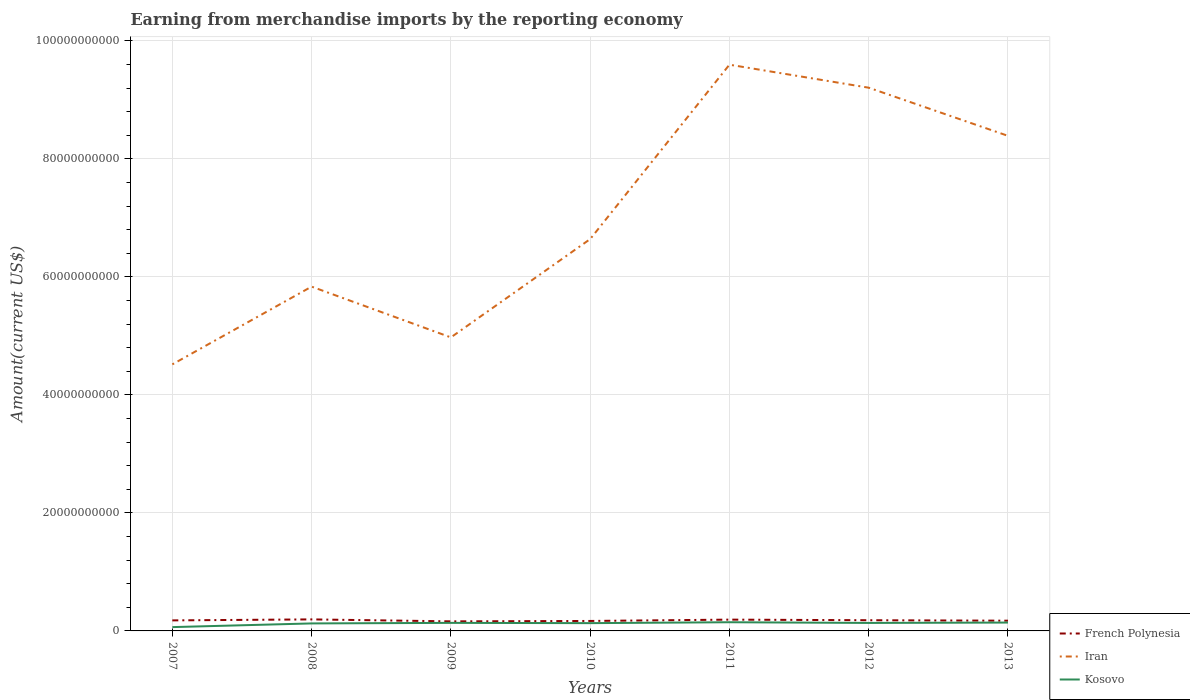How many different coloured lines are there?
Ensure brevity in your answer.  3. Is the number of lines equal to the number of legend labels?
Provide a succinct answer. Yes. Across all years, what is the maximum amount earned from merchandise imports in Iran?
Your response must be concise. 4.52e+1. What is the total amount earned from merchandise imports in Kosovo in the graph?
Your answer should be compact. -7.72e+08. What is the difference between the highest and the second highest amount earned from merchandise imports in French Polynesia?
Ensure brevity in your answer.  3.34e+08. Is the amount earned from merchandise imports in Kosovo strictly greater than the amount earned from merchandise imports in Iran over the years?
Offer a terse response. Yes. How many lines are there?
Your answer should be very brief. 3. What is the difference between two consecutive major ticks on the Y-axis?
Your response must be concise. 2.00e+1. Does the graph contain any zero values?
Your answer should be very brief. No. How many legend labels are there?
Give a very brief answer. 3. How are the legend labels stacked?
Provide a short and direct response. Vertical. What is the title of the graph?
Your answer should be compact. Earning from merchandise imports by the reporting economy. Does "Uganda" appear as one of the legend labels in the graph?
Your answer should be compact. No. What is the label or title of the Y-axis?
Your answer should be very brief. Amount(current US$). What is the Amount(current US$) of French Polynesia in 2007?
Provide a short and direct response. 1.78e+09. What is the Amount(current US$) of Iran in 2007?
Give a very brief answer. 4.52e+1. What is the Amount(current US$) of Kosovo in 2007?
Your answer should be very brief. 6.45e+08. What is the Amount(current US$) of French Polynesia in 2008?
Provide a succinct answer. 1.95e+09. What is the Amount(current US$) of Iran in 2008?
Your response must be concise. 5.83e+1. What is the Amount(current US$) of Kosovo in 2008?
Give a very brief answer. 1.27e+09. What is the Amount(current US$) in French Polynesia in 2009?
Your answer should be very brief. 1.62e+09. What is the Amount(current US$) of Iran in 2009?
Offer a very short reply. 4.97e+1. What is the Amount(current US$) in Kosovo in 2009?
Keep it short and to the point. 1.36e+09. What is the Amount(current US$) in French Polynesia in 2010?
Give a very brief answer. 1.69e+09. What is the Amount(current US$) in Iran in 2010?
Provide a short and direct response. 6.64e+1. What is the Amount(current US$) in Kosovo in 2010?
Your response must be concise. 1.32e+09. What is the Amount(current US$) of French Polynesia in 2011?
Offer a very short reply. 1.91e+09. What is the Amount(current US$) of Iran in 2011?
Ensure brevity in your answer.  9.59e+1. What is the Amount(current US$) in Kosovo in 2011?
Provide a succinct answer. 1.47e+09. What is the Amount(current US$) in French Polynesia in 2012?
Your answer should be very brief. 1.81e+09. What is the Amount(current US$) in Iran in 2012?
Offer a very short reply. 9.21e+1. What is the Amount(current US$) of Kosovo in 2012?
Offer a very short reply. 1.35e+09. What is the Amount(current US$) of French Polynesia in 2013?
Give a very brief answer. 1.73e+09. What is the Amount(current US$) in Iran in 2013?
Your response must be concise. 8.39e+1. What is the Amount(current US$) in Kosovo in 2013?
Give a very brief answer. 1.42e+09. Across all years, what is the maximum Amount(current US$) in French Polynesia?
Your answer should be compact. 1.95e+09. Across all years, what is the maximum Amount(current US$) in Iran?
Provide a succinct answer. 9.59e+1. Across all years, what is the maximum Amount(current US$) of Kosovo?
Offer a very short reply. 1.47e+09. Across all years, what is the minimum Amount(current US$) of French Polynesia?
Ensure brevity in your answer.  1.62e+09. Across all years, what is the minimum Amount(current US$) in Iran?
Your response must be concise. 4.52e+1. Across all years, what is the minimum Amount(current US$) of Kosovo?
Make the answer very short. 6.45e+08. What is the total Amount(current US$) of French Polynesia in the graph?
Provide a succinct answer. 1.25e+1. What is the total Amount(current US$) in Iran in the graph?
Ensure brevity in your answer.  4.92e+11. What is the total Amount(current US$) of Kosovo in the graph?
Provide a short and direct response. 8.84e+09. What is the difference between the Amount(current US$) in French Polynesia in 2007 and that in 2008?
Ensure brevity in your answer.  -1.70e+08. What is the difference between the Amount(current US$) of Iran in 2007 and that in 2008?
Offer a terse response. -1.32e+1. What is the difference between the Amount(current US$) of Kosovo in 2007 and that in 2008?
Your answer should be compact. -6.26e+08. What is the difference between the Amount(current US$) in French Polynesia in 2007 and that in 2009?
Ensure brevity in your answer.  1.64e+08. What is the difference between the Amount(current US$) in Iran in 2007 and that in 2009?
Your answer should be compact. -4.57e+09. What is the difference between the Amount(current US$) in Kosovo in 2007 and that in 2009?
Keep it short and to the point. -7.19e+08. What is the difference between the Amount(current US$) in French Polynesia in 2007 and that in 2010?
Your answer should be very brief. 9.64e+07. What is the difference between the Amount(current US$) in Iran in 2007 and that in 2010?
Ensure brevity in your answer.  -2.12e+1. What is the difference between the Amount(current US$) of Kosovo in 2007 and that in 2010?
Your answer should be compact. -6.74e+08. What is the difference between the Amount(current US$) of French Polynesia in 2007 and that in 2011?
Provide a succinct answer. -1.29e+08. What is the difference between the Amount(current US$) in Iran in 2007 and that in 2011?
Offer a terse response. -5.08e+1. What is the difference between the Amount(current US$) in Kosovo in 2007 and that in 2011?
Your answer should be very brief. -8.27e+08. What is the difference between the Amount(current US$) in French Polynesia in 2007 and that in 2012?
Make the answer very short. -2.76e+07. What is the difference between the Amount(current US$) of Iran in 2007 and that in 2012?
Make the answer very short. -4.69e+1. What is the difference between the Amount(current US$) in Kosovo in 2007 and that in 2012?
Offer a very short reply. -7.07e+08. What is the difference between the Amount(current US$) in French Polynesia in 2007 and that in 2013?
Your answer should be very brief. 5.14e+07. What is the difference between the Amount(current US$) of Iran in 2007 and that in 2013?
Provide a short and direct response. -3.87e+1. What is the difference between the Amount(current US$) of Kosovo in 2007 and that in 2013?
Make the answer very short. -7.72e+08. What is the difference between the Amount(current US$) in French Polynesia in 2008 and that in 2009?
Offer a terse response. 3.34e+08. What is the difference between the Amount(current US$) in Iran in 2008 and that in 2009?
Provide a short and direct response. 8.60e+09. What is the difference between the Amount(current US$) of Kosovo in 2008 and that in 2009?
Ensure brevity in your answer.  -9.32e+07. What is the difference between the Amount(current US$) in French Polynesia in 2008 and that in 2010?
Ensure brevity in your answer.  2.66e+08. What is the difference between the Amount(current US$) in Iran in 2008 and that in 2010?
Offer a very short reply. -8.05e+09. What is the difference between the Amount(current US$) of Kosovo in 2008 and that in 2010?
Keep it short and to the point. -4.82e+07. What is the difference between the Amount(current US$) in French Polynesia in 2008 and that in 2011?
Provide a short and direct response. 4.01e+07. What is the difference between the Amount(current US$) in Iran in 2008 and that in 2011?
Offer a terse response. -3.76e+1. What is the difference between the Amount(current US$) of Kosovo in 2008 and that in 2011?
Provide a succinct answer. -2.01e+08. What is the difference between the Amount(current US$) in French Polynesia in 2008 and that in 2012?
Provide a short and direct response. 1.42e+08. What is the difference between the Amount(current US$) of Iran in 2008 and that in 2012?
Give a very brief answer. -3.37e+1. What is the difference between the Amount(current US$) of Kosovo in 2008 and that in 2012?
Your response must be concise. -8.09e+07. What is the difference between the Amount(current US$) in French Polynesia in 2008 and that in 2013?
Your answer should be compact. 2.21e+08. What is the difference between the Amount(current US$) in Iran in 2008 and that in 2013?
Provide a short and direct response. -2.55e+1. What is the difference between the Amount(current US$) in Kosovo in 2008 and that in 2013?
Offer a very short reply. -1.46e+08. What is the difference between the Amount(current US$) of French Polynesia in 2009 and that in 2010?
Your answer should be compact. -6.78e+07. What is the difference between the Amount(current US$) of Iran in 2009 and that in 2010?
Make the answer very short. -1.67e+1. What is the difference between the Amount(current US$) of Kosovo in 2009 and that in 2010?
Offer a very short reply. 4.51e+07. What is the difference between the Amount(current US$) of French Polynesia in 2009 and that in 2011?
Make the answer very short. -2.94e+08. What is the difference between the Amount(current US$) of Iran in 2009 and that in 2011?
Your answer should be compact. -4.62e+1. What is the difference between the Amount(current US$) in Kosovo in 2009 and that in 2011?
Offer a very short reply. -1.08e+08. What is the difference between the Amount(current US$) in French Polynesia in 2009 and that in 2012?
Provide a succinct answer. -1.92e+08. What is the difference between the Amount(current US$) in Iran in 2009 and that in 2012?
Your answer should be compact. -4.23e+1. What is the difference between the Amount(current US$) in Kosovo in 2009 and that in 2012?
Provide a short and direct response. 1.23e+07. What is the difference between the Amount(current US$) of French Polynesia in 2009 and that in 2013?
Your answer should be very brief. -1.13e+08. What is the difference between the Amount(current US$) of Iran in 2009 and that in 2013?
Offer a terse response. -3.42e+1. What is the difference between the Amount(current US$) in Kosovo in 2009 and that in 2013?
Offer a terse response. -5.29e+07. What is the difference between the Amount(current US$) of French Polynesia in 2010 and that in 2011?
Offer a very short reply. -2.26e+08. What is the difference between the Amount(current US$) of Iran in 2010 and that in 2011?
Provide a succinct answer. -2.96e+1. What is the difference between the Amount(current US$) in Kosovo in 2010 and that in 2011?
Your answer should be compact. -1.53e+08. What is the difference between the Amount(current US$) in French Polynesia in 2010 and that in 2012?
Your response must be concise. -1.24e+08. What is the difference between the Amount(current US$) of Iran in 2010 and that in 2012?
Provide a short and direct response. -2.57e+1. What is the difference between the Amount(current US$) in Kosovo in 2010 and that in 2012?
Ensure brevity in your answer.  -3.27e+07. What is the difference between the Amount(current US$) of French Polynesia in 2010 and that in 2013?
Offer a very short reply. -4.50e+07. What is the difference between the Amount(current US$) in Iran in 2010 and that in 2013?
Make the answer very short. -1.75e+1. What is the difference between the Amount(current US$) in Kosovo in 2010 and that in 2013?
Provide a short and direct response. -9.80e+07. What is the difference between the Amount(current US$) of French Polynesia in 2011 and that in 2012?
Your response must be concise. 1.02e+08. What is the difference between the Amount(current US$) of Iran in 2011 and that in 2012?
Keep it short and to the point. 3.90e+09. What is the difference between the Amount(current US$) in Kosovo in 2011 and that in 2012?
Give a very brief answer. 1.20e+08. What is the difference between the Amount(current US$) in French Polynesia in 2011 and that in 2013?
Provide a short and direct response. 1.81e+08. What is the difference between the Amount(current US$) in Iran in 2011 and that in 2013?
Ensure brevity in your answer.  1.21e+1. What is the difference between the Amount(current US$) in Kosovo in 2011 and that in 2013?
Provide a succinct answer. 5.49e+07. What is the difference between the Amount(current US$) of French Polynesia in 2012 and that in 2013?
Provide a short and direct response. 7.90e+07. What is the difference between the Amount(current US$) of Iran in 2012 and that in 2013?
Make the answer very short. 8.16e+09. What is the difference between the Amount(current US$) of Kosovo in 2012 and that in 2013?
Provide a short and direct response. -6.52e+07. What is the difference between the Amount(current US$) in French Polynesia in 2007 and the Amount(current US$) in Iran in 2008?
Provide a succinct answer. -5.66e+1. What is the difference between the Amount(current US$) in French Polynesia in 2007 and the Amount(current US$) in Kosovo in 2008?
Your answer should be very brief. 5.13e+08. What is the difference between the Amount(current US$) in Iran in 2007 and the Amount(current US$) in Kosovo in 2008?
Make the answer very short. 4.39e+1. What is the difference between the Amount(current US$) of French Polynesia in 2007 and the Amount(current US$) of Iran in 2009?
Give a very brief answer. -4.80e+1. What is the difference between the Amount(current US$) in French Polynesia in 2007 and the Amount(current US$) in Kosovo in 2009?
Offer a very short reply. 4.20e+08. What is the difference between the Amount(current US$) of Iran in 2007 and the Amount(current US$) of Kosovo in 2009?
Ensure brevity in your answer.  4.38e+1. What is the difference between the Amount(current US$) of French Polynesia in 2007 and the Amount(current US$) of Iran in 2010?
Your answer should be very brief. -6.46e+1. What is the difference between the Amount(current US$) in French Polynesia in 2007 and the Amount(current US$) in Kosovo in 2010?
Make the answer very short. 4.65e+08. What is the difference between the Amount(current US$) of Iran in 2007 and the Amount(current US$) of Kosovo in 2010?
Provide a succinct answer. 4.38e+1. What is the difference between the Amount(current US$) of French Polynesia in 2007 and the Amount(current US$) of Iran in 2011?
Provide a succinct answer. -9.42e+1. What is the difference between the Amount(current US$) in French Polynesia in 2007 and the Amount(current US$) in Kosovo in 2011?
Your answer should be compact. 3.12e+08. What is the difference between the Amount(current US$) of Iran in 2007 and the Amount(current US$) of Kosovo in 2011?
Your answer should be compact. 4.37e+1. What is the difference between the Amount(current US$) in French Polynesia in 2007 and the Amount(current US$) in Iran in 2012?
Your response must be concise. -9.03e+1. What is the difference between the Amount(current US$) of French Polynesia in 2007 and the Amount(current US$) of Kosovo in 2012?
Keep it short and to the point. 4.33e+08. What is the difference between the Amount(current US$) in Iran in 2007 and the Amount(current US$) in Kosovo in 2012?
Make the answer very short. 4.38e+1. What is the difference between the Amount(current US$) of French Polynesia in 2007 and the Amount(current US$) of Iran in 2013?
Keep it short and to the point. -8.21e+1. What is the difference between the Amount(current US$) of French Polynesia in 2007 and the Amount(current US$) of Kosovo in 2013?
Provide a succinct answer. 3.67e+08. What is the difference between the Amount(current US$) of Iran in 2007 and the Amount(current US$) of Kosovo in 2013?
Offer a terse response. 4.38e+1. What is the difference between the Amount(current US$) of French Polynesia in 2008 and the Amount(current US$) of Iran in 2009?
Your answer should be very brief. -4.78e+1. What is the difference between the Amount(current US$) in French Polynesia in 2008 and the Amount(current US$) in Kosovo in 2009?
Your answer should be compact. 5.90e+08. What is the difference between the Amount(current US$) in Iran in 2008 and the Amount(current US$) in Kosovo in 2009?
Your answer should be compact. 5.70e+1. What is the difference between the Amount(current US$) in French Polynesia in 2008 and the Amount(current US$) in Iran in 2010?
Offer a very short reply. -6.44e+1. What is the difference between the Amount(current US$) in French Polynesia in 2008 and the Amount(current US$) in Kosovo in 2010?
Keep it short and to the point. 6.35e+08. What is the difference between the Amount(current US$) in Iran in 2008 and the Amount(current US$) in Kosovo in 2010?
Your answer should be compact. 5.70e+1. What is the difference between the Amount(current US$) of French Polynesia in 2008 and the Amount(current US$) of Iran in 2011?
Offer a very short reply. -9.40e+1. What is the difference between the Amount(current US$) in French Polynesia in 2008 and the Amount(current US$) in Kosovo in 2011?
Your answer should be compact. 4.82e+08. What is the difference between the Amount(current US$) of Iran in 2008 and the Amount(current US$) of Kosovo in 2011?
Provide a succinct answer. 5.69e+1. What is the difference between the Amount(current US$) of French Polynesia in 2008 and the Amount(current US$) of Iran in 2012?
Offer a terse response. -9.01e+1. What is the difference between the Amount(current US$) in French Polynesia in 2008 and the Amount(current US$) in Kosovo in 2012?
Your response must be concise. 6.02e+08. What is the difference between the Amount(current US$) of Iran in 2008 and the Amount(current US$) of Kosovo in 2012?
Your response must be concise. 5.70e+1. What is the difference between the Amount(current US$) in French Polynesia in 2008 and the Amount(current US$) in Iran in 2013?
Make the answer very short. -8.19e+1. What is the difference between the Amount(current US$) of French Polynesia in 2008 and the Amount(current US$) of Kosovo in 2013?
Your response must be concise. 5.37e+08. What is the difference between the Amount(current US$) of Iran in 2008 and the Amount(current US$) of Kosovo in 2013?
Provide a short and direct response. 5.69e+1. What is the difference between the Amount(current US$) in French Polynesia in 2009 and the Amount(current US$) in Iran in 2010?
Give a very brief answer. -6.48e+1. What is the difference between the Amount(current US$) of French Polynesia in 2009 and the Amount(current US$) of Kosovo in 2010?
Provide a succinct answer. 3.01e+08. What is the difference between the Amount(current US$) of Iran in 2009 and the Amount(current US$) of Kosovo in 2010?
Offer a terse response. 4.84e+1. What is the difference between the Amount(current US$) in French Polynesia in 2009 and the Amount(current US$) in Iran in 2011?
Make the answer very short. -9.43e+1. What is the difference between the Amount(current US$) in French Polynesia in 2009 and the Amount(current US$) in Kosovo in 2011?
Offer a terse response. 1.48e+08. What is the difference between the Amount(current US$) in Iran in 2009 and the Amount(current US$) in Kosovo in 2011?
Make the answer very short. 4.83e+1. What is the difference between the Amount(current US$) of French Polynesia in 2009 and the Amount(current US$) of Iran in 2012?
Keep it short and to the point. -9.04e+1. What is the difference between the Amount(current US$) in French Polynesia in 2009 and the Amount(current US$) in Kosovo in 2012?
Offer a terse response. 2.68e+08. What is the difference between the Amount(current US$) of Iran in 2009 and the Amount(current US$) of Kosovo in 2012?
Make the answer very short. 4.84e+1. What is the difference between the Amount(current US$) in French Polynesia in 2009 and the Amount(current US$) in Iran in 2013?
Provide a succinct answer. -8.23e+1. What is the difference between the Amount(current US$) in French Polynesia in 2009 and the Amount(current US$) in Kosovo in 2013?
Give a very brief answer. 2.03e+08. What is the difference between the Amount(current US$) of Iran in 2009 and the Amount(current US$) of Kosovo in 2013?
Provide a succinct answer. 4.83e+1. What is the difference between the Amount(current US$) in French Polynesia in 2010 and the Amount(current US$) in Iran in 2011?
Offer a terse response. -9.43e+1. What is the difference between the Amount(current US$) in French Polynesia in 2010 and the Amount(current US$) in Kosovo in 2011?
Keep it short and to the point. 2.16e+08. What is the difference between the Amount(current US$) of Iran in 2010 and the Amount(current US$) of Kosovo in 2011?
Your response must be concise. 6.49e+1. What is the difference between the Amount(current US$) of French Polynesia in 2010 and the Amount(current US$) of Iran in 2012?
Ensure brevity in your answer.  -9.04e+1. What is the difference between the Amount(current US$) of French Polynesia in 2010 and the Amount(current US$) of Kosovo in 2012?
Keep it short and to the point. 3.36e+08. What is the difference between the Amount(current US$) of Iran in 2010 and the Amount(current US$) of Kosovo in 2012?
Offer a terse response. 6.50e+1. What is the difference between the Amount(current US$) of French Polynesia in 2010 and the Amount(current US$) of Iran in 2013?
Offer a very short reply. -8.22e+1. What is the difference between the Amount(current US$) in French Polynesia in 2010 and the Amount(current US$) in Kosovo in 2013?
Offer a terse response. 2.71e+08. What is the difference between the Amount(current US$) of Iran in 2010 and the Amount(current US$) of Kosovo in 2013?
Offer a very short reply. 6.50e+1. What is the difference between the Amount(current US$) in French Polynesia in 2011 and the Amount(current US$) in Iran in 2012?
Keep it short and to the point. -9.01e+1. What is the difference between the Amount(current US$) of French Polynesia in 2011 and the Amount(current US$) of Kosovo in 2012?
Keep it short and to the point. 5.62e+08. What is the difference between the Amount(current US$) in Iran in 2011 and the Amount(current US$) in Kosovo in 2012?
Give a very brief answer. 9.46e+1. What is the difference between the Amount(current US$) in French Polynesia in 2011 and the Amount(current US$) in Iran in 2013?
Your answer should be very brief. -8.20e+1. What is the difference between the Amount(current US$) in French Polynesia in 2011 and the Amount(current US$) in Kosovo in 2013?
Your answer should be compact. 4.97e+08. What is the difference between the Amount(current US$) in Iran in 2011 and the Amount(current US$) in Kosovo in 2013?
Offer a terse response. 9.45e+1. What is the difference between the Amount(current US$) in French Polynesia in 2012 and the Amount(current US$) in Iran in 2013?
Make the answer very short. -8.21e+1. What is the difference between the Amount(current US$) of French Polynesia in 2012 and the Amount(current US$) of Kosovo in 2013?
Offer a very short reply. 3.95e+08. What is the difference between the Amount(current US$) in Iran in 2012 and the Amount(current US$) in Kosovo in 2013?
Your answer should be compact. 9.06e+1. What is the average Amount(current US$) in French Polynesia per year?
Keep it short and to the point. 1.79e+09. What is the average Amount(current US$) of Iran per year?
Make the answer very short. 7.02e+1. What is the average Amount(current US$) of Kosovo per year?
Offer a terse response. 1.26e+09. In the year 2007, what is the difference between the Amount(current US$) in French Polynesia and Amount(current US$) in Iran?
Give a very brief answer. -4.34e+1. In the year 2007, what is the difference between the Amount(current US$) in French Polynesia and Amount(current US$) in Kosovo?
Offer a very short reply. 1.14e+09. In the year 2007, what is the difference between the Amount(current US$) in Iran and Amount(current US$) in Kosovo?
Your response must be concise. 4.45e+1. In the year 2008, what is the difference between the Amount(current US$) of French Polynesia and Amount(current US$) of Iran?
Keep it short and to the point. -5.64e+1. In the year 2008, what is the difference between the Amount(current US$) of French Polynesia and Amount(current US$) of Kosovo?
Your answer should be compact. 6.83e+08. In the year 2008, what is the difference between the Amount(current US$) of Iran and Amount(current US$) of Kosovo?
Your answer should be compact. 5.71e+1. In the year 2009, what is the difference between the Amount(current US$) in French Polynesia and Amount(current US$) in Iran?
Provide a short and direct response. -4.81e+1. In the year 2009, what is the difference between the Amount(current US$) of French Polynesia and Amount(current US$) of Kosovo?
Your answer should be very brief. 2.56e+08. In the year 2009, what is the difference between the Amount(current US$) of Iran and Amount(current US$) of Kosovo?
Provide a succinct answer. 4.84e+1. In the year 2010, what is the difference between the Amount(current US$) in French Polynesia and Amount(current US$) in Iran?
Provide a succinct answer. -6.47e+1. In the year 2010, what is the difference between the Amount(current US$) in French Polynesia and Amount(current US$) in Kosovo?
Offer a terse response. 3.69e+08. In the year 2010, what is the difference between the Amount(current US$) of Iran and Amount(current US$) of Kosovo?
Offer a terse response. 6.51e+1. In the year 2011, what is the difference between the Amount(current US$) of French Polynesia and Amount(current US$) of Iran?
Make the answer very short. -9.40e+1. In the year 2011, what is the difference between the Amount(current US$) of French Polynesia and Amount(current US$) of Kosovo?
Your answer should be compact. 4.42e+08. In the year 2011, what is the difference between the Amount(current US$) in Iran and Amount(current US$) in Kosovo?
Your answer should be compact. 9.45e+1. In the year 2012, what is the difference between the Amount(current US$) in French Polynesia and Amount(current US$) in Iran?
Offer a terse response. -9.02e+1. In the year 2012, what is the difference between the Amount(current US$) in French Polynesia and Amount(current US$) in Kosovo?
Offer a terse response. 4.60e+08. In the year 2012, what is the difference between the Amount(current US$) in Iran and Amount(current US$) in Kosovo?
Your response must be concise. 9.07e+1. In the year 2013, what is the difference between the Amount(current US$) in French Polynesia and Amount(current US$) in Iran?
Provide a succinct answer. -8.22e+1. In the year 2013, what is the difference between the Amount(current US$) in French Polynesia and Amount(current US$) in Kosovo?
Give a very brief answer. 3.16e+08. In the year 2013, what is the difference between the Amount(current US$) in Iran and Amount(current US$) in Kosovo?
Your answer should be very brief. 8.25e+1. What is the ratio of the Amount(current US$) in French Polynesia in 2007 to that in 2008?
Provide a succinct answer. 0.91. What is the ratio of the Amount(current US$) in Iran in 2007 to that in 2008?
Your answer should be compact. 0.77. What is the ratio of the Amount(current US$) in Kosovo in 2007 to that in 2008?
Provide a succinct answer. 0.51. What is the ratio of the Amount(current US$) in French Polynesia in 2007 to that in 2009?
Make the answer very short. 1.1. What is the ratio of the Amount(current US$) of Iran in 2007 to that in 2009?
Your answer should be compact. 0.91. What is the ratio of the Amount(current US$) of Kosovo in 2007 to that in 2009?
Offer a very short reply. 0.47. What is the ratio of the Amount(current US$) in French Polynesia in 2007 to that in 2010?
Offer a very short reply. 1.06. What is the ratio of the Amount(current US$) of Iran in 2007 to that in 2010?
Offer a terse response. 0.68. What is the ratio of the Amount(current US$) of Kosovo in 2007 to that in 2010?
Provide a short and direct response. 0.49. What is the ratio of the Amount(current US$) of French Polynesia in 2007 to that in 2011?
Ensure brevity in your answer.  0.93. What is the ratio of the Amount(current US$) of Iran in 2007 to that in 2011?
Provide a short and direct response. 0.47. What is the ratio of the Amount(current US$) of Kosovo in 2007 to that in 2011?
Give a very brief answer. 0.44. What is the ratio of the Amount(current US$) in Iran in 2007 to that in 2012?
Keep it short and to the point. 0.49. What is the ratio of the Amount(current US$) of Kosovo in 2007 to that in 2012?
Keep it short and to the point. 0.48. What is the ratio of the Amount(current US$) in French Polynesia in 2007 to that in 2013?
Your answer should be compact. 1.03. What is the ratio of the Amount(current US$) in Iran in 2007 to that in 2013?
Ensure brevity in your answer.  0.54. What is the ratio of the Amount(current US$) of Kosovo in 2007 to that in 2013?
Your answer should be very brief. 0.46. What is the ratio of the Amount(current US$) of French Polynesia in 2008 to that in 2009?
Ensure brevity in your answer.  1.21. What is the ratio of the Amount(current US$) of Iran in 2008 to that in 2009?
Offer a terse response. 1.17. What is the ratio of the Amount(current US$) in Kosovo in 2008 to that in 2009?
Keep it short and to the point. 0.93. What is the ratio of the Amount(current US$) in French Polynesia in 2008 to that in 2010?
Offer a terse response. 1.16. What is the ratio of the Amount(current US$) of Iran in 2008 to that in 2010?
Provide a short and direct response. 0.88. What is the ratio of the Amount(current US$) in Kosovo in 2008 to that in 2010?
Provide a short and direct response. 0.96. What is the ratio of the Amount(current US$) of French Polynesia in 2008 to that in 2011?
Your response must be concise. 1.02. What is the ratio of the Amount(current US$) of Iran in 2008 to that in 2011?
Your response must be concise. 0.61. What is the ratio of the Amount(current US$) of Kosovo in 2008 to that in 2011?
Your answer should be very brief. 0.86. What is the ratio of the Amount(current US$) in French Polynesia in 2008 to that in 2012?
Provide a short and direct response. 1.08. What is the ratio of the Amount(current US$) of Iran in 2008 to that in 2012?
Ensure brevity in your answer.  0.63. What is the ratio of the Amount(current US$) in Kosovo in 2008 to that in 2012?
Provide a succinct answer. 0.94. What is the ratio of the Amount(current US$) in French Polynesia in 2008 to that in 2013?
Provide a short and direct response. 1.13. What is the ratio of the Amount(current US$) of Iran in 2008 to that in 2013?
Provide a short and direct response. 0.7. What is the ratio of the Amount(current US$) of Kosovo in 2008 to that in 2013?
Offer a terse response. 0.9. What is the ratio of the Amount(current US$) of French Polynesia in 2009 to that in 2010?
Ensure brevity in your answer.  0.96. What is the ratio of the Amount(current US$) in Iran in 2009 to that in 2010?
Your response must be concise. 0.75. What is the ratio of the Amount(current US$) in Kosovo in 2009 to that in 2010?
Make the answer very short. 1.03. What is the ratio of the Amount(current US$) in French Polynesia in 2009 to that in 2011?
Your answer should be compact. 0.85. What is the ratio of the Amount(current US$) of Iran in 2009 to that in 2011?
Your answer should be very brief. 0.52. What is the ratio of the Amount(current US$) in Kosovo in 2009 to that in 2011?
Give a very brief answer. 0.93. What is the ratio of the Amount(current US$) in French Polynesia in 2009 to that in 2012?
Make the answer very short. 0.89. What is the ratio of the Amount(current US$) in Iran in 2009 to that in 2012?
Give a very brief answer. 0.54. What is the ratio of the Amount(current US$) of Kosovo in 2009 to that in 2012?
Provide a short and direct response. 1.01. What is the ratio of the Amount(current US$) of French Polynesia in 2009 to that in 2013?
Your answer should be very brief. 0.93. What is the ratio of the Amount(current US$) of Iran in 2009 to that in 2013?
Make the answer very short. 0.59. What is the ratio of the Amount(current US$) of Kosovo in 2009 to that in 2013?
Keep it short and to the point. 0.96. What is the ratio of the Amount(current US$) of French Polynesia in 2010 to that in 2011?
Offer a very short reply. 0.88. What is the ratio of the Amount(current US$) of Iran in 2010 to that in 2011?
Your response must be concise. 0.69. What is the ratio of the Amount(current US$) in Kosovo in 2010 to that in 2011?
Offer a very short reply. 0.9. What is the ratio of the Amount(current US$) in French Polynesia in 2010 to that in 2012?
Your answer should be compact. 0.93. What is the ratio of the Amount(current US$) in Iran in 2010 to that in 2012?
Provide a succinct answer. 0.72. What is the ratio of the Amount(current US$) of Kosovo in 2010 to that in 2012?
Provide a short and direct response. 0.98. What is the ratio of the Amount(current US$) in Iran in 2010 to that in 2013?
Offer a very short reply. 0.79. What is the ratio of the Amount(current US$) of Kosovo in 2010 to that in 2013?
Make the answer very short. 0.93. What is the ratio of the Amount(current US$) in French Polynesia in 2011 to that in 2012?
Your answer should be very brief. 1.06. What is the ratio of the Amount(current US$) in Iran in 2011 to that in 2012?
Keep it short and to the point. 1.04. What is the ratio of the Amount(current US$) of Kosovo in 2011 to that in 2012?
Offer a very short reply. 1.09. What is the ratio of the Amount(current US$) of French Polynesia in 2011 to that in 2013?
Your answer should be compact. 1.1. What is the ratio of the Amount(current US$) in Iran in 2011 to that in 2013?
Your answer should be compact. 1.14. What is the ratio of the Amount(current US$) in Kosovo in 2011 to that in 2013?
Offer a terse response. 1.04. What is the ratio of the Amount(current US$) in French Polynesia in 2012 to that in 2013?
Your answer should be compact. 1.05. What is the ratio of the Amount(current US$) in Iran in 2012 to that in 2013?
Make the answer very short. 1.1. What is the ratio of the Amount(current US$) in Kosovo in 2012 to that in 2013?
Give a very brief answer. 0.95. What is the difference between the highest and the second highest Amount(current US$) in French Polynesia?
Your response must be concise. 4.01e+07. What is the difference between the highest and the second highest Amount(current US$) of Iran?
Offer a terse response. 3.90e+09. What is the difference between the highest and the second highest Amount(current US$) of Kosovo?
Provide a short and direct response. 5.49e+07. What is the difference between the highest and the lowest Amount(current US$) of French Polynesia?
Offer a very short reply. 3.34e+08. What is the difference between the highest and the lowest Amount(current US$) in Iran?
Make the answer very short. 5.08e+1. What is the difference between the highest and the lowest Amount(current US$) in Kosovo?
Your answer should be very brief. 8.27e+08. 